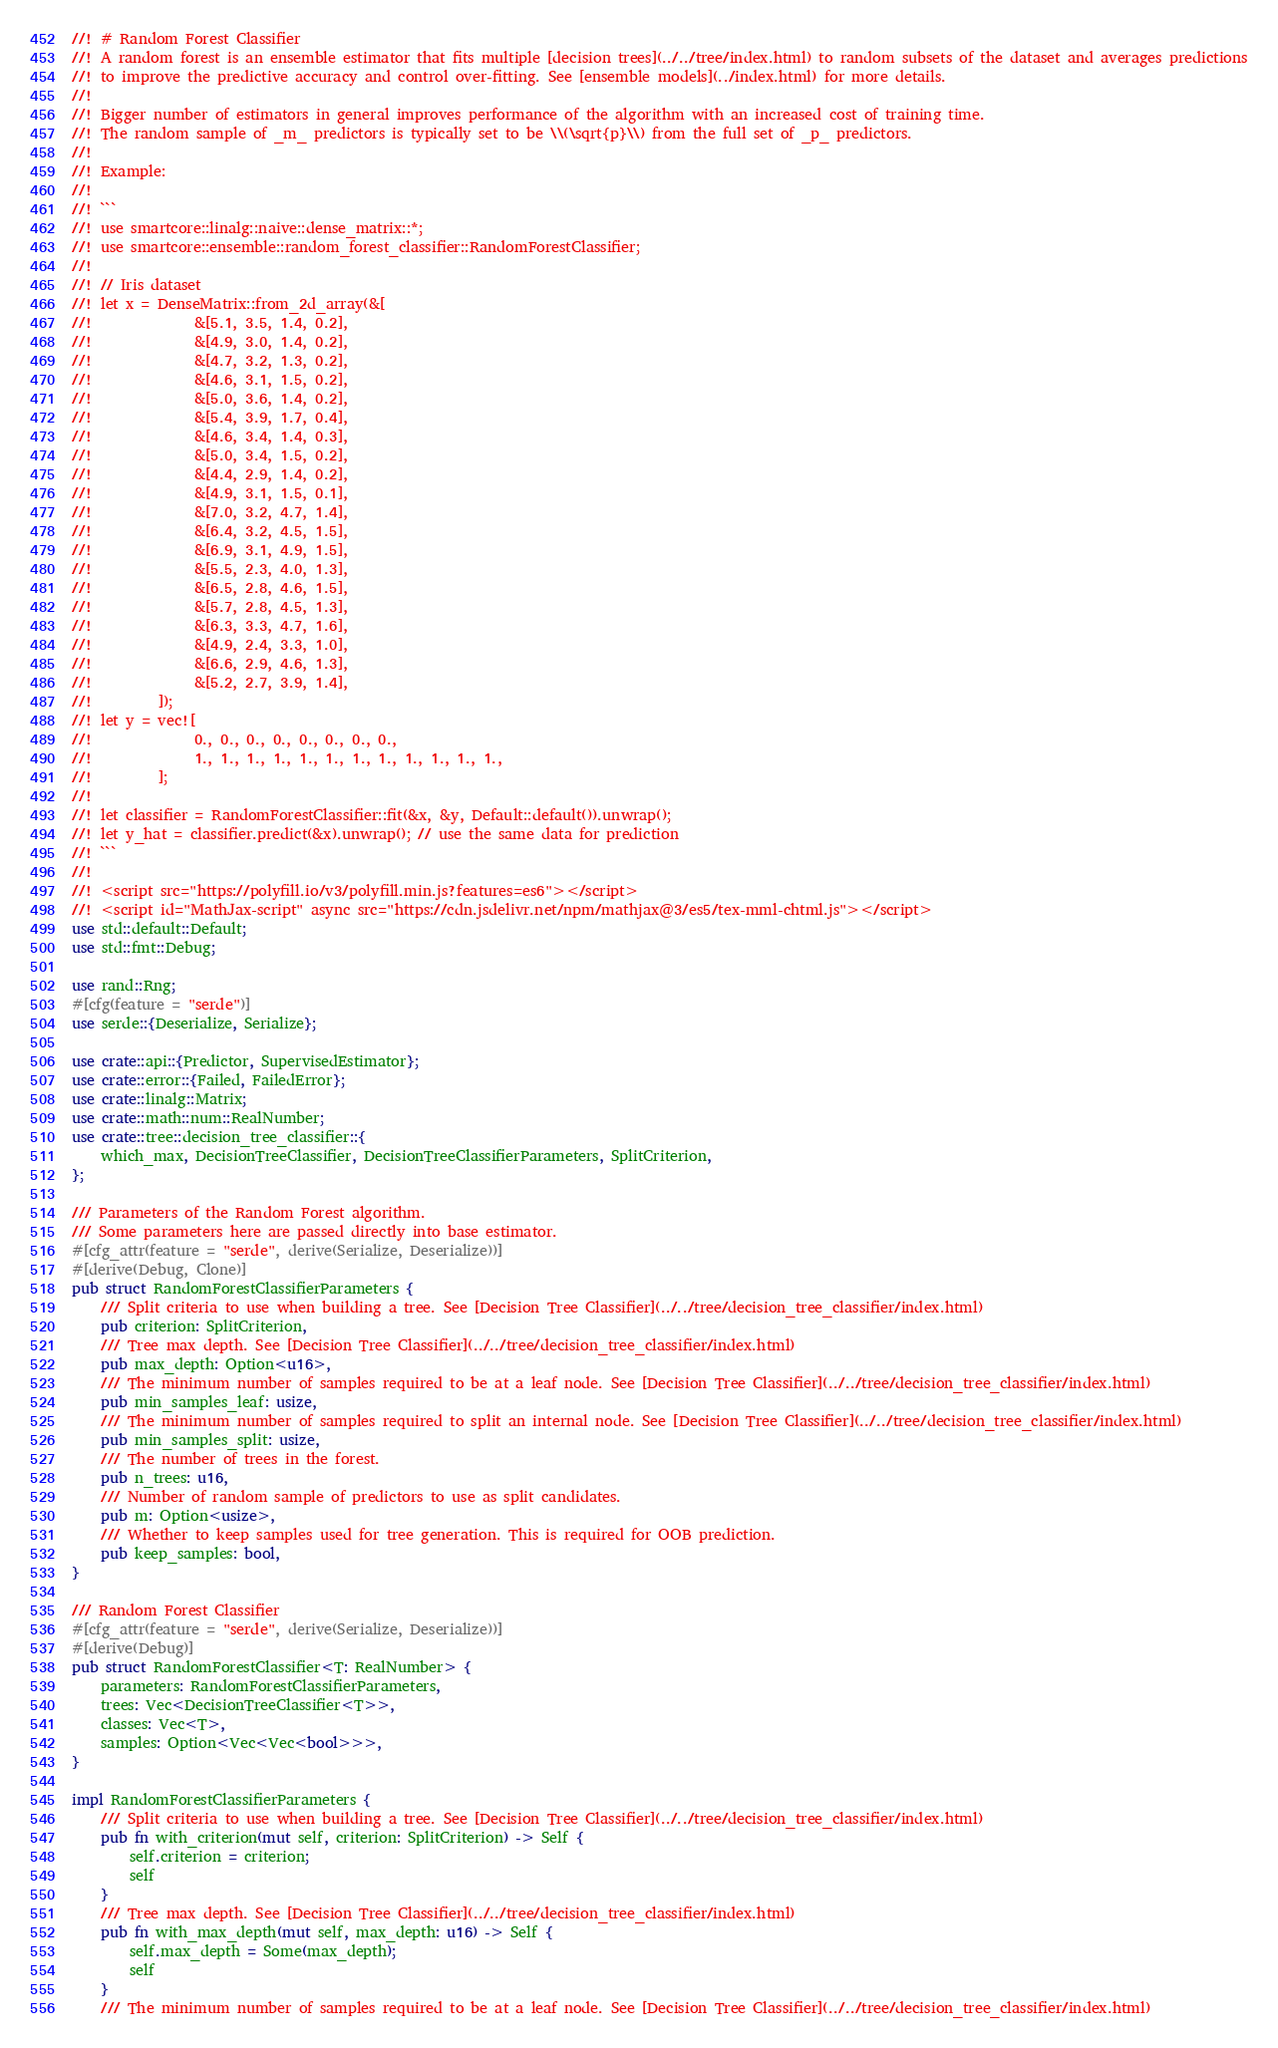<code> <loc_0><loc_0><loc_500><loc_500><_Rust_>//! # Random Forest Classifier
//! A random forest is an ensemble estimator that fits multiple [decision trees](../../tree/index.html) to random subsets of the dataset and averages predictions
//! to improve the predictive accuracy and control over-fitting. See [ensemble models](../index.html) for more details.
//!
//! Bigger number of estimators in general improves performance of the algorithm with an increased cost of training time.
//! The random sample of _m_ predictors is typically set to be \\(\sqrt{p}\\) from the full set of _p_ predictors.
//!
//! Example:
//!
//! ```
//! use smartcore::linalg::naive::dense_matrix::*;
//! use smartcore::ensemble::random_forest_classifier::RandomForestClassifier;
//!
//! // Iris dataset
//! let x = DenseMatrix::from_2d_array(&[
//!              &[5.1, 3.5, 1.4, 0.2],
//!              &[4.9, 3.0, 1.4, 0.2],
//!              &[4.7, 3.2, 1.3, 0.2],
//!              &[4.6, 3.1, 1.5, 0.2],
//!              &[5.0, 3.6, 1.4, 0.2],
//!              &[5.4, 3.9, 1.7, 0.4],
//!              &[4.6, 3.4, 1.4, 0.3],
//!              &[5.0, 3.4, 1.5, 0.2],
//!              &[4.4, 2.9, 1.4, 0.2],
//!              &[4.9, 3.1, 1.5, 0.1],
//!              &[7.0, 3.2, 4.7, 1.4],
//!              &[6.4, 3.2, 4.5, 1.5],
//!              &[6.9, 3.1, 4.9, 1.5],
//!              &[5.5, 2.3, 4.0, 1.3],
//!              &[6.5, 2.8, 4.6, 1.5],
//!              &[5.7, 2.8, 4.5, 1.3],
//!              &[6.3, 3.3, 4.7, 1.6],
//!              &[4.9, 2.4, 3.3, 1.0],
//!              &[6.6, 2.9, 4.6, 1.3],
//!              &[5.2, 2.7, 3.9, 1.4],
//!         ]);
//! let y = vec![
//!              0., 0., 0., 0., 0., 0., 0., 0.,
//!              1., 1., 1., 1., 1., 1., 1., 1., 1., 1., 1., 1.,
//!         ];
//!
//! let classifier = RandomForestClassifier::fit(&x, &y, Default::default()).unwrap();
//! let y_hat = classifier.predict(&x).unwrap(); // use the same data for prediction
//! ```
//!
//! <script src="https://polyfill.io/v3/polyfill.min.js?features=es6"></script>
//! <script id="MathJax-script" async src="https://cdn.jsdelivr.net/npm/mathjax@3/es5/tex-mml-chtml.js"></script>
use std::default::Default;
use std::fmt::Debug;

use rand::Rng;
#[cfg(feature = "serde")]
use serde::{Deserialize, Serialize};

use crate::api::{Predictor, SupervisedEstimator};
use crate::error::{Failed, FailedError};
use crate::linalg::Matrix;
use crate::math::num::RealNumber;
use crate::tree::decision_tree_classifier::{
    which_max, DecisionTreeClassifier, DecisionTreeClassifierParameters, SplitCriterion,
};

/// Parameters of the Random Forest algorithm.
/// Some parameters here are passed directly into base estimator.
#[cfg_attr(feature = "serde", derive(Serialize, Deserialize))]
#[derive(Debug, Clone)]
pub struct RandomForestClassifierParameters {
    /// Split criteria to use when building a tree. See [Decision Tree Classifier](../../tree/decision_tree_classifier/index.html)
    pub criterion: SplitCriterion,
    /// Tree max depth. See [Decision Tree Classifier](../../tree/decision_tree_classifier/index.html)
    pub max_depth: Option<u16>,
    /// The minimum number of samples required to be at a leaf node. See [Decision Tree Classifier](../../tree/decision_tree_classifier/index.html)
    pub min_samples_leaf: usize,
    /// The minimum number of samples required to split an internal node. See [Decision Tree Classifier](../../tree/decision_tree_classifier/index.html)
    pub min_samples_split: usize,
    /// The number of trees in the forest.
    pub n_trees: u16,
    /// Number of random sample of predictors to use as split candidates.
    pub m: Option<usize>,
    /// Whether to keep samples used for tree generation. This is required for OOB prediction.
    pub keep_samples: bool,
}

/// Random Forest Classifier
#[cfg_attr(feature = "serde", derive(Serialize, Deserialize))]
#[derive(Debug)]
pub struct RandomForestClassifier<T: RealNumber> {
    parameters: RandomForestClassifierParameters,
    trees: Vec<DecisionTreeClassifier<T>>,
    classes: Vec<T>,
    samples: Option<Vec<Vec<bool>>>,
}

impl RandomForestClassifierParameters {
    /// Split criteria to use when building a tree. See [Decision Tree Classifier](../../tree/decision_tree_classifier/index.html)
    pub fn with_criterion(mut self, criterion: SplitCriterion) -> Self {
        self.criterion = criterion;
        self
    }
    /// Tree max depth. See [Decision Tree Classifier](../../tree/decision_tree_classifier/index.html)
    pub fn with_max_depth(mut self, max_depth: u16) -> Self {
        self.max_depth = Some(max_depth);
        self
    }
    /// The minimum number of samples required to be at a leaf node. See [Decision Tree Classifier](../../tree/decision_tree_classifier/index.html)</code> 